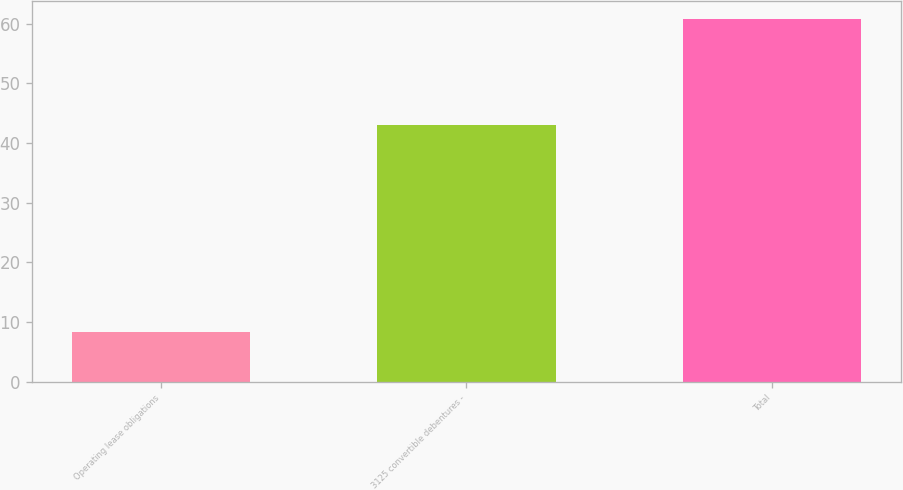<chart> <loc_0><loc_0><loc_500><loc_500><bar_chart><fcel>Operating lease obligations<fcel>3125 convertible debentures -<fcel>Total<nl><fcel>8.4<fcel>43.1<fcel>60.8<nl></chart> 